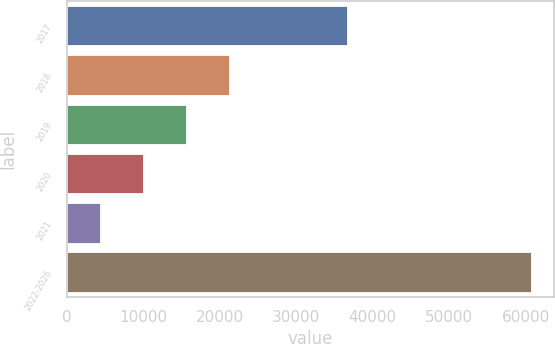Convert chart to OTSL. <chart><loc_0><loc_0><loc_500><loc_500><bar_chart><fcel>2017<fcel>2018<fcel>2019<fcel>2020<fcel>2021<fcel>2022-2026<nl><fcel>36604<fcel>21211.6<fcel>15576.4<fcel>9941.2<fcel>4306<fcel>60658<nl></chart> 